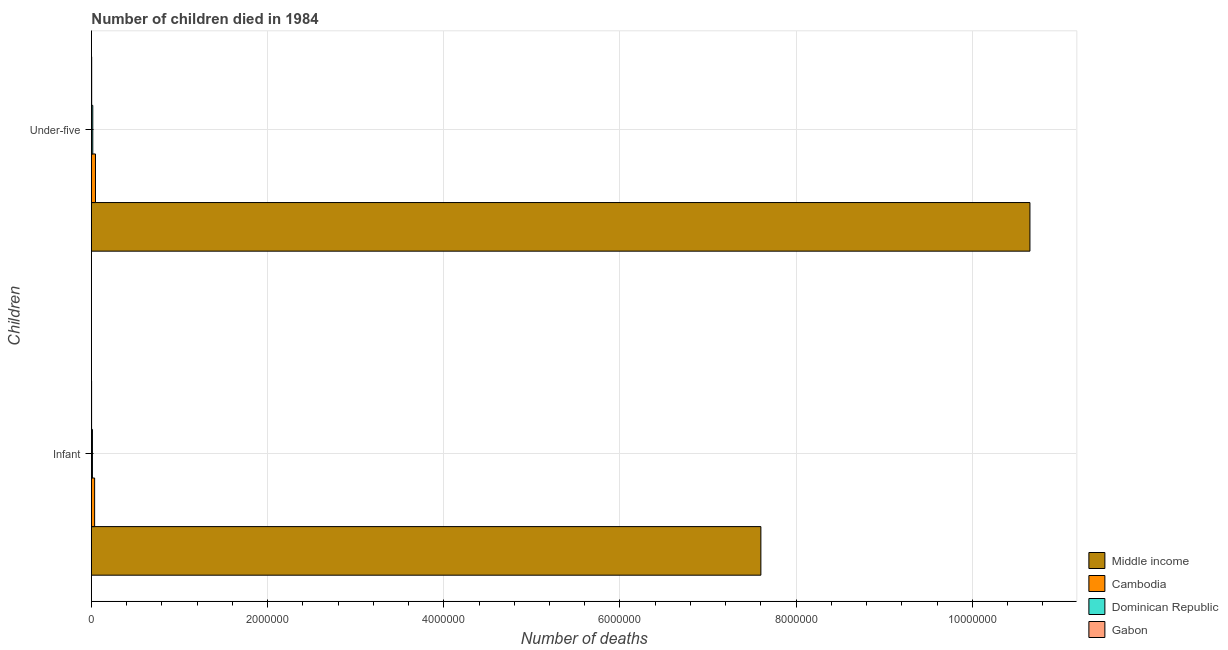Are the number of bars per tick equal to the number of legend labels?
Make the answer very short. Yes. Are the number of bars on each tick of the Y-axis equal?
Offer a terse response. Yes. How many bars are there on the 2nd tick from the top?
Offer a terse response. 4. What is the label of the 1st group of bars from the top?
Provide a succinct answer. Under-five. What is the number of infant deaths in Middle income?
Offer a terse response. 7.60e+06. Across all countries, what is the maximum number of infant deaths?
Your answer should be very brief. 7.60e+06. In which country was the number of under-five deaths minimum?
Your answer should be compact. Gabon. What is the total number of infant deaths in the graph?
Your response must be concise. 7.65e+06. What is the difference between the number of under-five deaths in Dominican Republic and that in Cambodia?
Your answer should be compact. -3.07e+04. What is the difference between the number of infant deaths in Cambodia and the number of under-five deaths in Gabon?
Offer a terse response. 3.34e+04. What is the average number of infant deaths per country?
Offer a terse response. 1.91e+06. What is the difference between the number of under-five deaths and number of infant deaths in Dominican Republic?
Give a very brief answer. 3794. In how many countries, is the number of under-five deaths greater than 8000000 ?
Offer a terse response. 1. What is the ratio of the number of infant deaths in Dominican Republic to that in Cambodia?
Make the answer very short. 0.32. What does the 2nd bar from the top in Under-five represents?
Offer a very short reply. Dominican Republic. What does the 1st bar from the bottom in Under-five represents?
Give a very brief answer. Middle income. How many bars are there?
Ensure brevity in your answer.  8. What is the difference between two consecutive major ticks on the X-axis?
Keep it short and to the point. 2.00e+06. Are the values on the major ticks of X-axis written in scientific E-notation?
Provide a short and direct response. No. Does the graph contain any zero values?
Give a very brief answer. No. How many legend labels are there?
Ensure brevity in your answer.  4. What is the title of the graph?
Give a very brief answer. Number of children died in 1984. Does "Syrian Arab Republic" appear as one of the legend labels in the graph?
Provide a short and direct response. No. What is the label or title of the X-axis?
Make the answer very short. Number of deaths. What is the label or title of the Y-axis?
Your answer should be very brief. Children. What is the Number of deaths in Middle income in Infant?
Your answer should be compact. 7.60e+06. What is the Number of deaths of Cambodia in Infant?
Give a very brief answer. 3.64e+04. What is the Number of deaths in Dominican Republic in Infant?
Keep it short and to the point. 1.16e+04. What is the Number of deaths of Gabon in Infant?
Provide a short and direct response. 1984. What is the Number of deaths of Middle income in Under-five?
Your response must be concise. 1.07e+07. What is the Number of deaths in Cambodia in Under-five?
Offer a very short reply. 4.60e+04. What is the Number of deaths of Dominican Republic in Under-five?
Offer a very short reply. 1.54e+04. What is the Number of deaths in Gabon in Under-five?
Provide a short and direct response. 3017. Across all Children, what is the maximum Number of deaths of Middle income?
Your answer should be very brief. 1.07e+07. Across all Children, what is the maximum Number of deaths of Cambodia?
Ensure brevity in your answer.  4.60e+04. Across all Children, what is the maximum Number of deaths in Dominican Republic?
Make the answer very short. 1.54e+04. Across all Children, what is the maximum Number of deaths of Gabon?
Offer a terse response. 3017. Across all Children, what is the minimum Number of deaths of Middle income?
Your response must be concise. 7.60e+06. Across all Children, what is the minimum Number of deaths in Cambodia?
Your answer should be compact. 3.64e+04. Across all Children, what is the minimum Number of deaths of Dominican Republic?
Offer a terse response. 1.16e+04. Across all Children, what is the minimum Number of deaths in Gabon?
Offer a terse response. 1984. What is the total Number of deaths in Middle income in the graph?
Provide a succinct answer. 1.83e+07. What is the total Number of deaths in Cambodia in the graph?
Your answer should be very brief. 8.25e+04. What is the total Number of deaths of Dominican Republic in the graph?
Make the answer very short. 2.70e+04. What is the total Number of deaths of Gabon in the graph?
Your answer should be very brief. 5001. What is the difference between the Number of deaths of Middle income in Infant and that in Under-five?
Provide a short and direct response. -3.05e+06. What is the difference between the Number of deaths in Cambodia in Infant and that in Under-five?
Provide a succinct answer. -9608. What is the difference between the Number of deaths in Dominican Republic in Infant and that in Under-five?
Keep it short and to the point. -3794. What is the difference between the Number of deaths of Gabon in Infant and that in Under-five?
Provide a short and direct response. -1033. What is the difference between the Number of deaths of Middle income in Infant and the Number of deaths of Cambodia in Under-five?
Make the answer very short. 7.55e+06. What is the difference between the Number of deaths in Middle income in Infant and the Number of deaths in Dominican Republic in Under-five?
Offer a very short reply. 7.58e+06. What is the difference between the Number of deaths in Middle income in Infant and the Number of deaths in Gabon in Under-five?
Provide a succinct answer. 7.60e+06. What is the difference between the Number of deaths in Cambodia in Infant and the Number of deaths in Dominican Republic in Under-five?
Provide a succinct answer. 2.11e+04. What is the difference between the Number of deaths in Cambodia in Infant and the Number of deaths in Gabon in Under-five?
Your response must be concise. 3.34e+04. What is the difference between the Number of deaths in Dominican Republic in Infant and the Number of deaths in Gabon in Under-five?
Offer a terse response. 8566. What is the average Number of deaths in Middle income per Children?
Make the answer very short. 9.13e+06. What is the average Number of deaths of Cambodia per Children?
Offer a very short reply. 4.12e+04. What is the average Number of deaths in Dominican Republic per Children?
Your response must be concise. 1.35e+04. What is the average Number of deaths in Gabon per Children?
Provide a succinct answer. 2500.5. What is the difference between the Number of deaths in Middle income and Number of deaths in Cambodia in Infant?
Keep it short and to the point. 7.56e+06. What is the difference between the Number of deaths of Middle income and Number of deaths of Dominican Republic in Infant?
Your response must be concise. 7.59e+06. What is the difference between the Number of deaths of Middle income and Number of deaths of Gabon in Infant?
Your response must be concise. 7.60e+06. What is the difference between the Number of deaths of Cambodia and Number of deaths of Dominican Republic in Infant?
Your response must be concise. 2.48e+04. What is the difference between the Number of deaths in Cambodia and Number of deaths in Gabon in Infant?
Ensure brevity in your answer.  3.44e+04. What is the difference between the Number of deaths of Dominican Republic and Number of deaths of Gabon in Infant?
Provide a short and direct response. 9599. What is the difference between the Number of deaths in Middle income and Number of deaths in Cambodia in Under-five?
Make the answer very short. 1.06e+07. What is the difference between the Number of deaths of Middle income and Number of deaths of Dominican Republic in Under-five?
Ensure brevity in your answer.  1.06e+07. What is the difference between the Number of deaths in Middle income and Number of deaths in Gabon in Under-five?
Ensure brevity in your answer.  1.07e+07. What is the difference between the Number of deaths in Cambodia and Number of deaths in Dominican Republic in Under-five?
Keep it short and to the point. 3.07e+04. What is the difference between the Number of deaths in Cambodia and Number of deaths in Gabon in Under-five?
Your answer should be compact. 4.30e+04. What is the difference between the Number of deaths in Dominican Republic and Number of deaths in Gabon in Under-five?
Keep it short and to the point. 1.24e+04. What is the ratio of the Number of deaths of Middle income in Infant to that in Under-five?
Ensure brevity in your answer.  0.71. What is the ratio of the Number of deaths in Cambodia in Infant to that in Under-five?
Your answer should be compact. 0.79. What is the ratio of the Number of deaths in Dominican Republic in Infant to that in Under-five?
Offer a very short reply. 0.75. What is the ratio of the Number of deaths of Gabon in Infant to that in Under-five?
Your answer should be very brief. 0.66. What is the difference between the highest and the second highest Number of deaths in Middle income?
Offer a very short reply. 3.05e+06. What is the difference between the highest and the second highest Number of deaths in Cambodia?
Offer a terse response. 9608. What is the difference between the highest and the second highest Number of deaths of Dominican Republic?
Give a very brief answer. 3794. What is the difference between the highest and the second highest Number of deaths in Gabon?
Give a very brief answer. 1033. What is the difference between the highest and the lowest Number of deaths in Middle income?
Provide a short and direct response. 3.05e+06. What is the difference between the highest and the lowest Number of deaths of Cambodia?
Your response must be concise. 9608. What is the difference between the highest and the lowest Number of deaths in Dominican Republic?
Your answer should be compact. 3794. What is the difference between the highest and the lowest Number of deaths of Gabon?
Ensure brevity in your answer.  1033. 